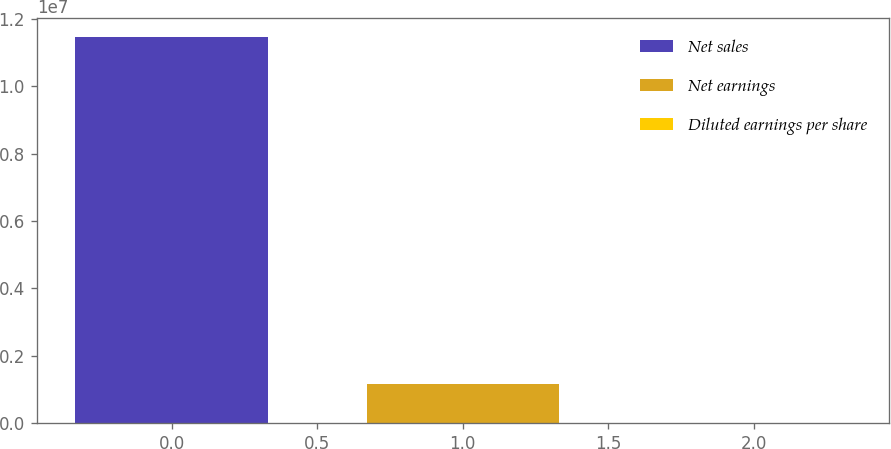Convert chart. <chart><loc_0><loc_0><loc_500><loc_500><bar_chart><fcel>Net sales<fcel>Net earnings<fcel>Diluted earnings per share<nl><fcel>1.14708e+07<fcel>1.1547e+06<fcel>3.47<nl></chart> 